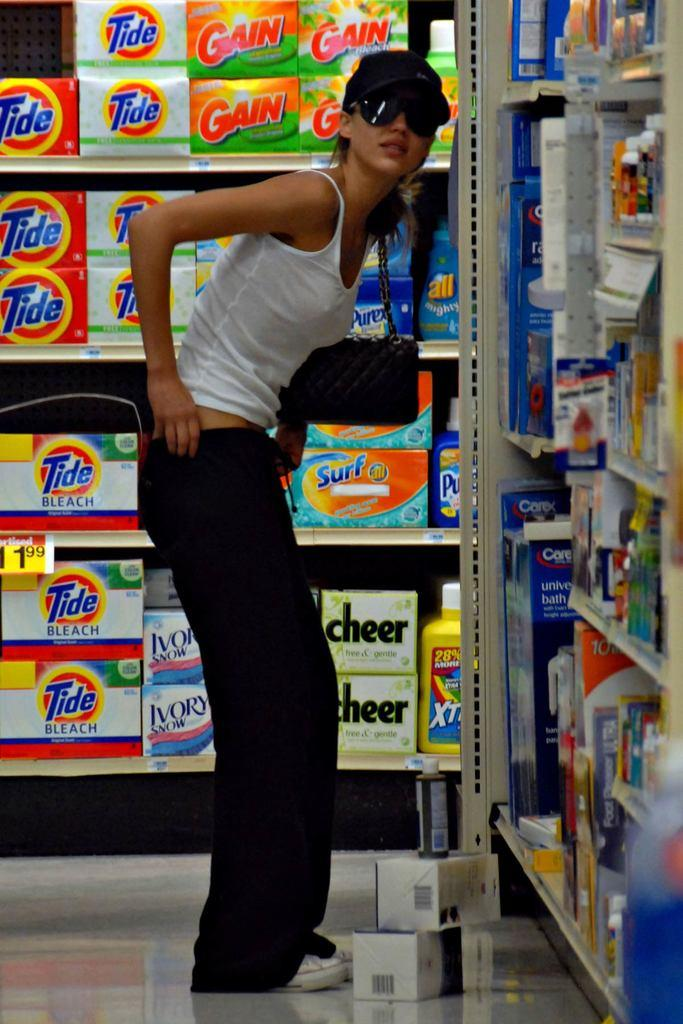<image>
Write a terse but informative summary of the picture. A woman, standing in a cleaning supplies aisle, pulling up her black pants. 